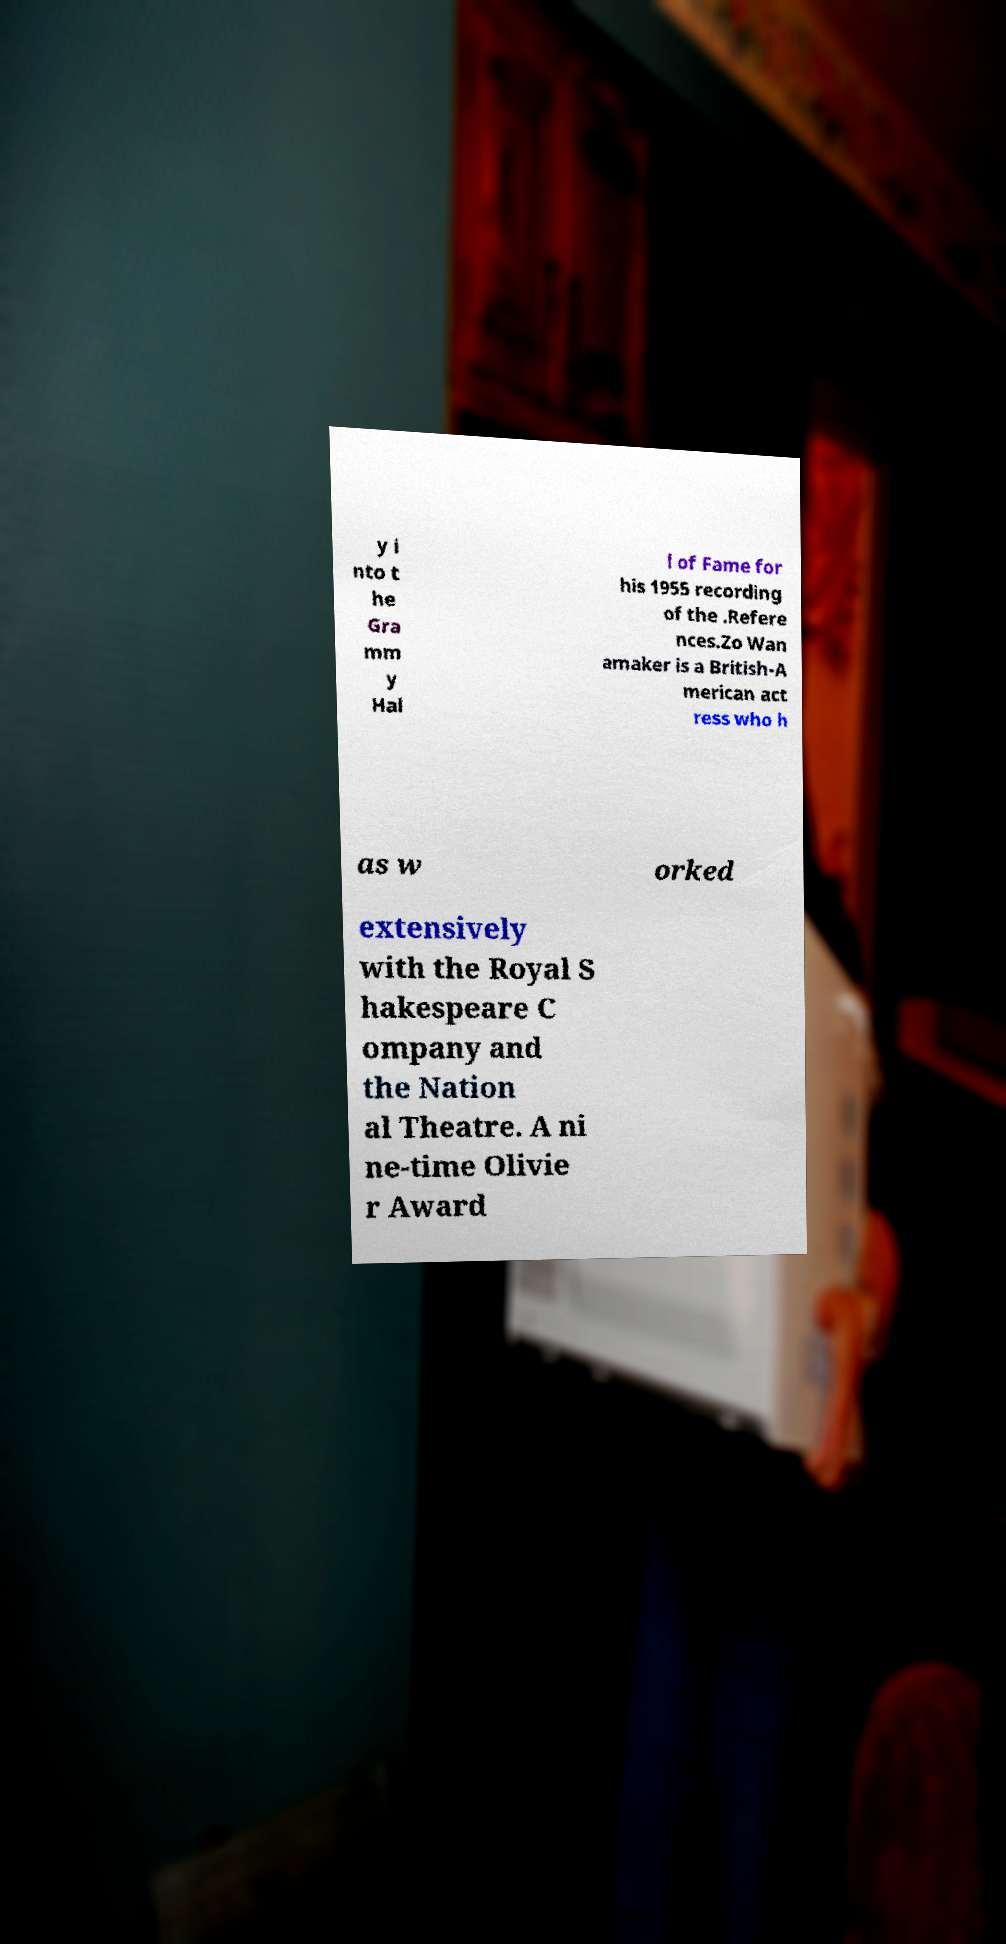What messages or text are displayed in this image? I need them in a readable, typed format. y i nto t he Gra mm y Hal l of Fame for his 1955 recording of the .Refere nces.Zo Wan amaker is a British-A merican act ress who h as w orked extensively with the Royal S hakespeare C ompany and the Nation al Theatre. A ni ne-time Olivie r Award 